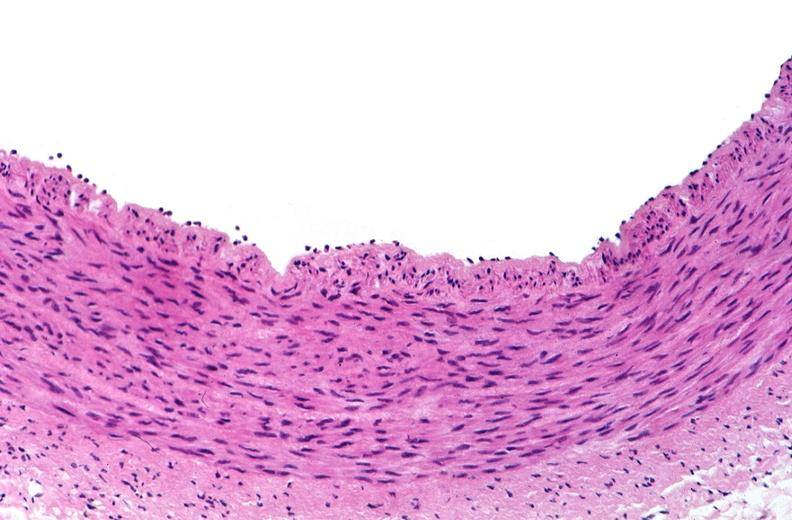s vasculature present?
Answer the question using a single word or phrase. Yes 